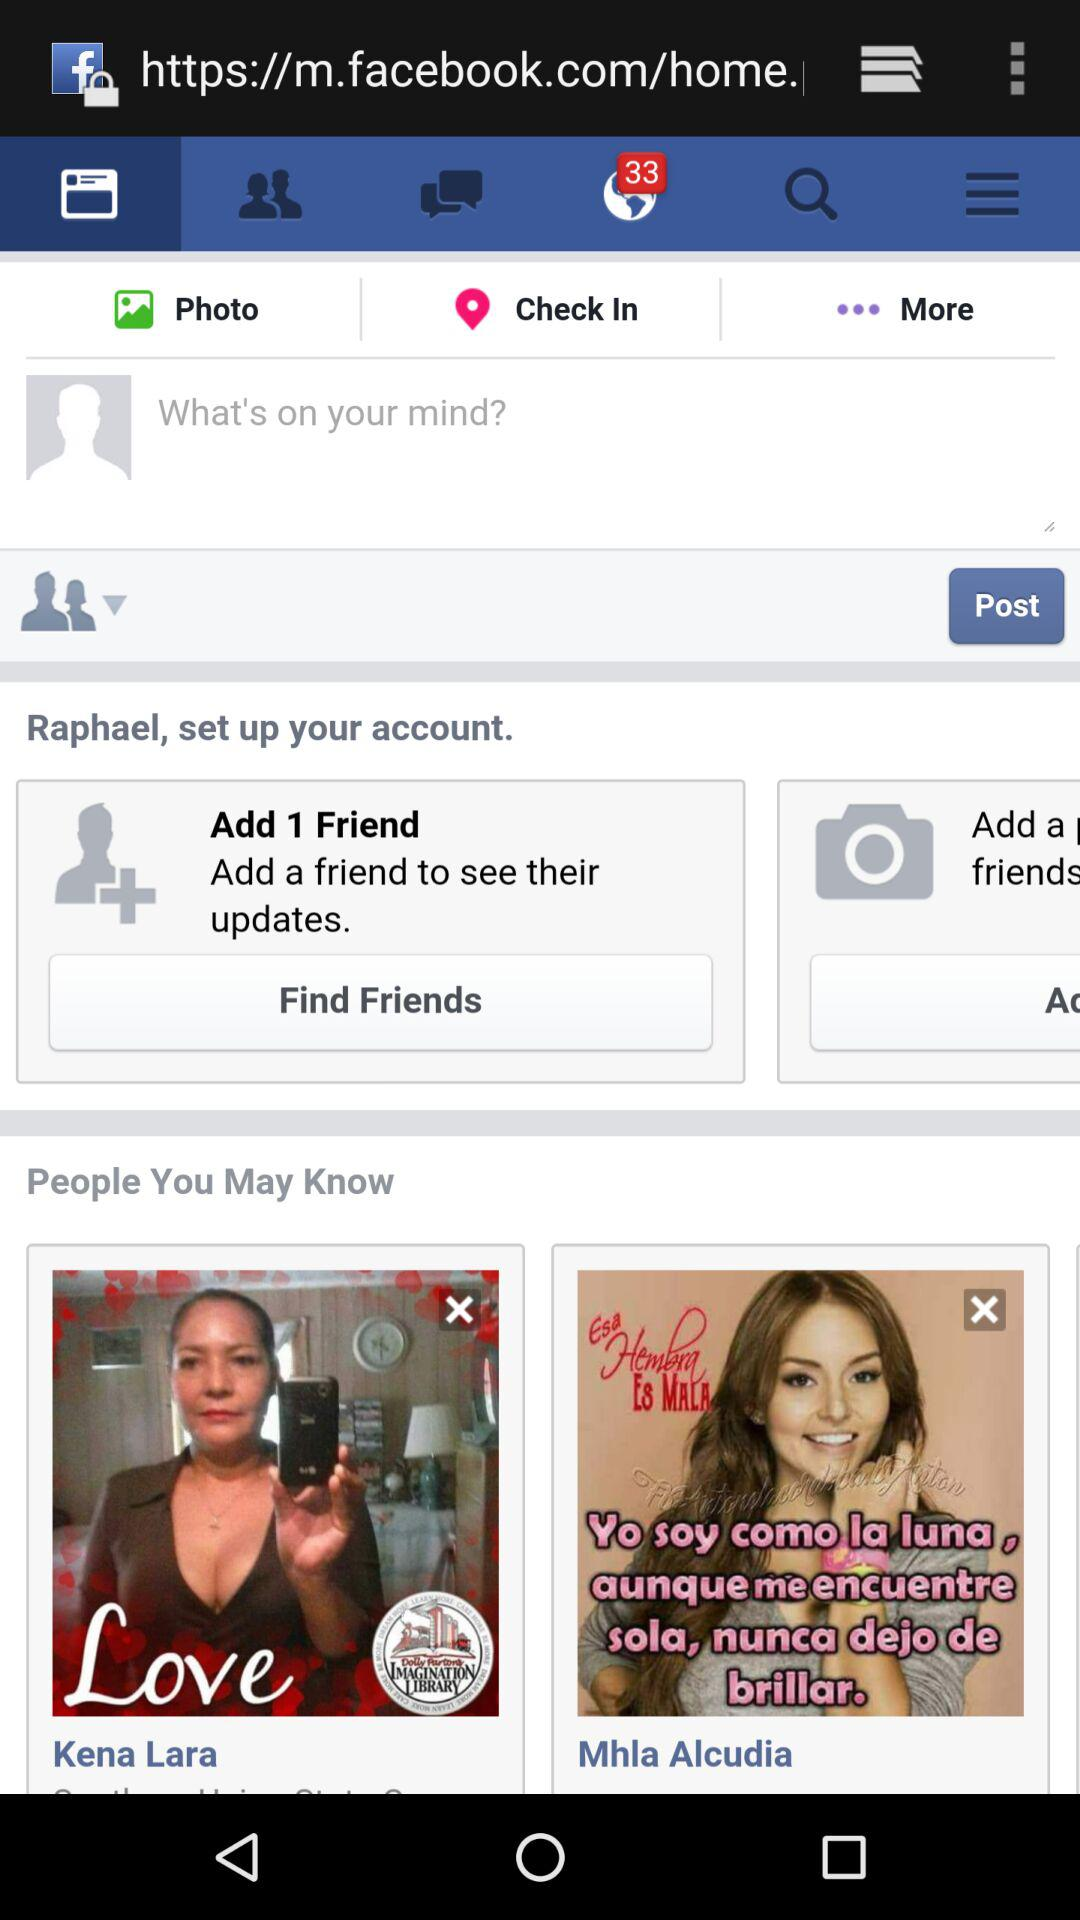How many notifications are there on "Facebook"? There are 33 notifications. 